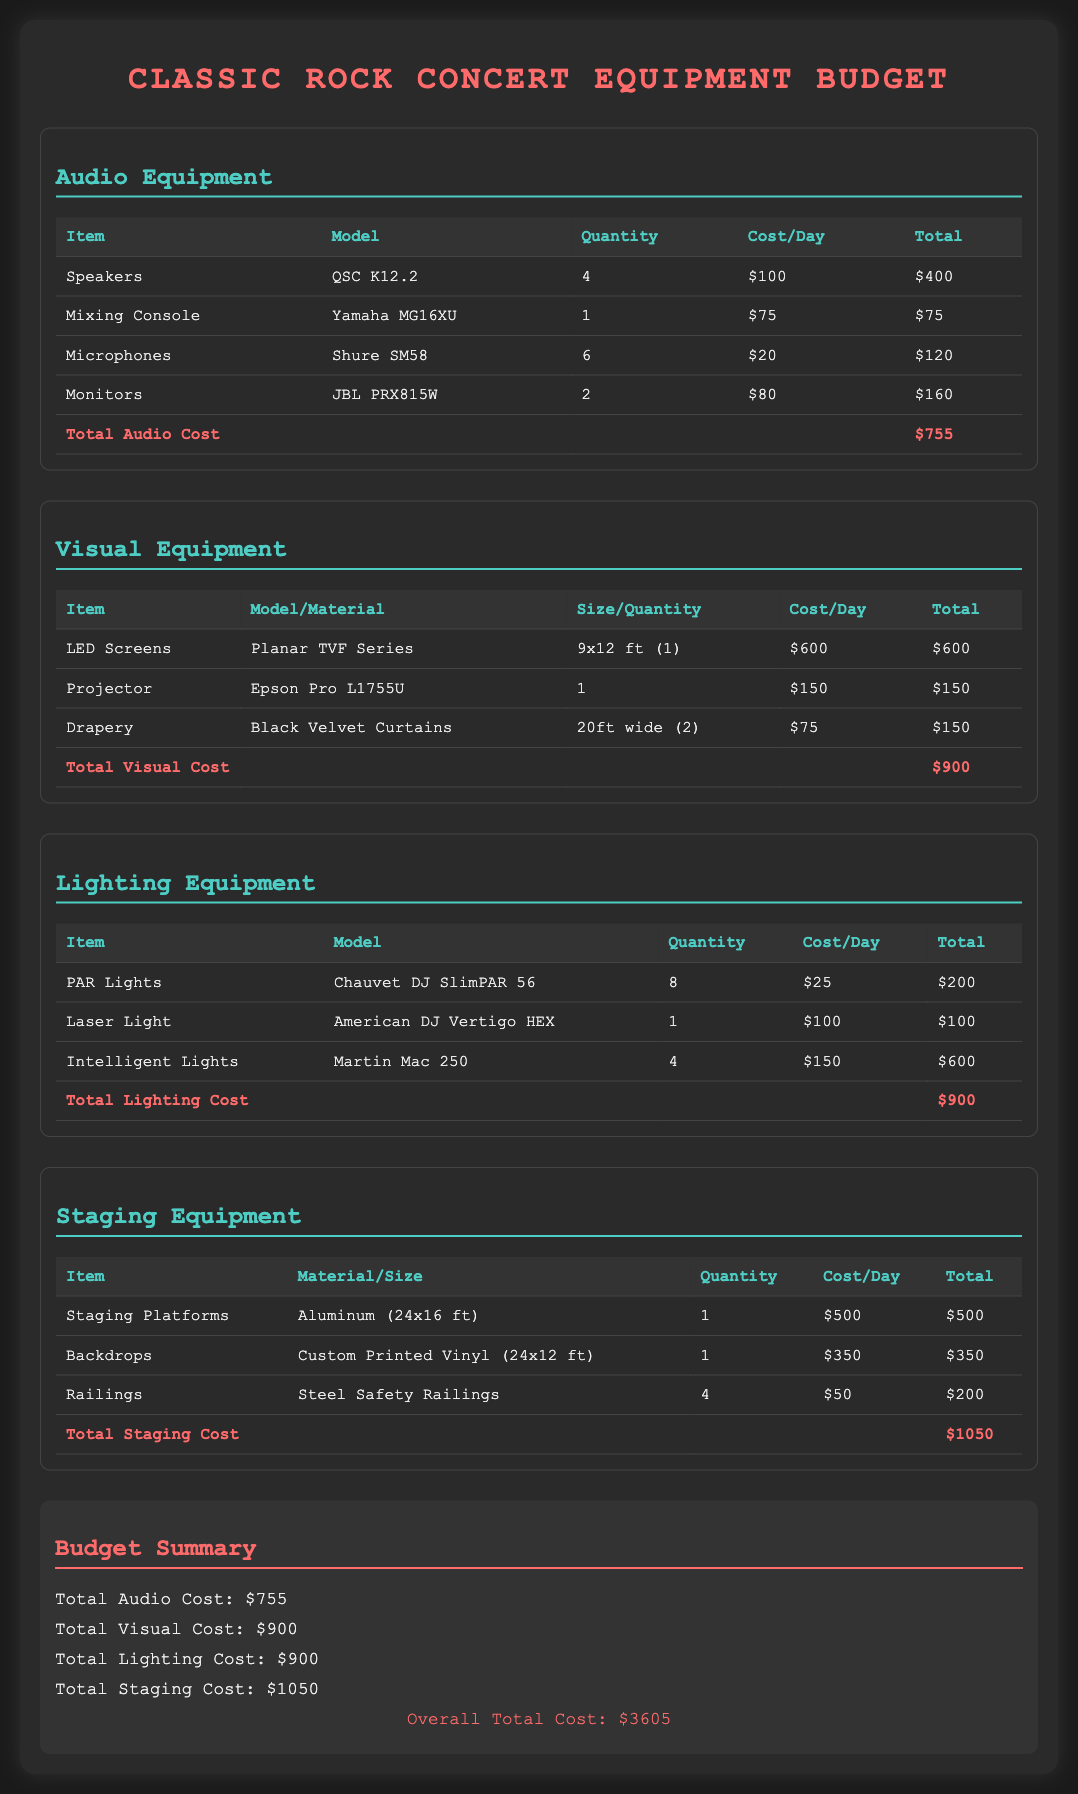What is the total audio cost? The total audio cost is provided at the bottom of the audio equipment section, which is $755.
Answer: $755 How many speakers are rented? The number of speakers is indicated in the audio equipment section, showing a quantity of 4.
Answer: 4 What is the cost of the LED screen rental? The rental cost for the LED screen is specified in the visual equipment section as $600.
Answer: $600 How many total items are listed in the lighting equipment section? The lighting equipment section lists three different items: PAR Lights, Laser Light, and Intelligent Lights.
Answer: 3 What is the model of the mixing console? The mixing console model is mentioned in the audio equipment section as Yamaha MG16XU.
Answer: Yamaha MG16XU What is the total cost for staging equipment? The total cost for staging equipment is summed up at the end of the staging equipment section, which is $1050.
Answer: $1050 Which item has the highest rental cost? The highest rental cost among all items is found in the staging equipment section for Staging Platforms which is $500.
Answer: Staging Platforms What is the overall total cost for all equipment? The overall total cost is provided in the budget summary section as the final amount, which is $3605.
Answer: $3605 How many microphones are included in the rental? The document states that there are 6 microphones rented in the audio equipment section.
Answer: 6 